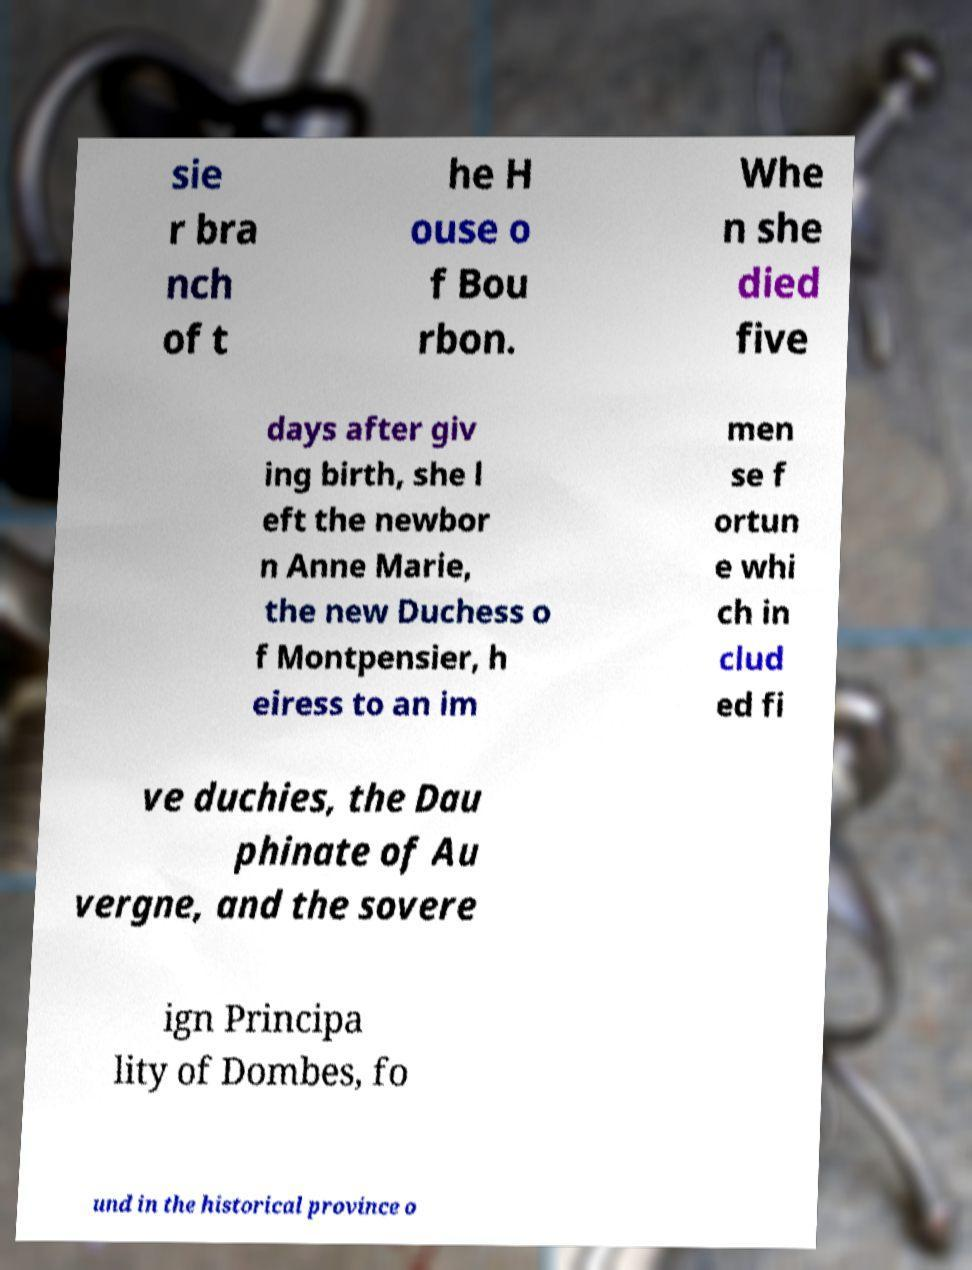For documentation purposes, I need the text within this image transcribed. Could you provide that? sie r bra nch of t he H ouse o f Bou rbon. Whe n she died five days after giv ing birth, she l eft the newbor n Anne Marie, the new Duchess o f Montpensier, h eiress to an im men se f ortun e whi ch in clud ed fi ve duchies, the Dau phinate of Au vergne, and the sovere ign Principa lity of Dombes, fo und in the historical province o 